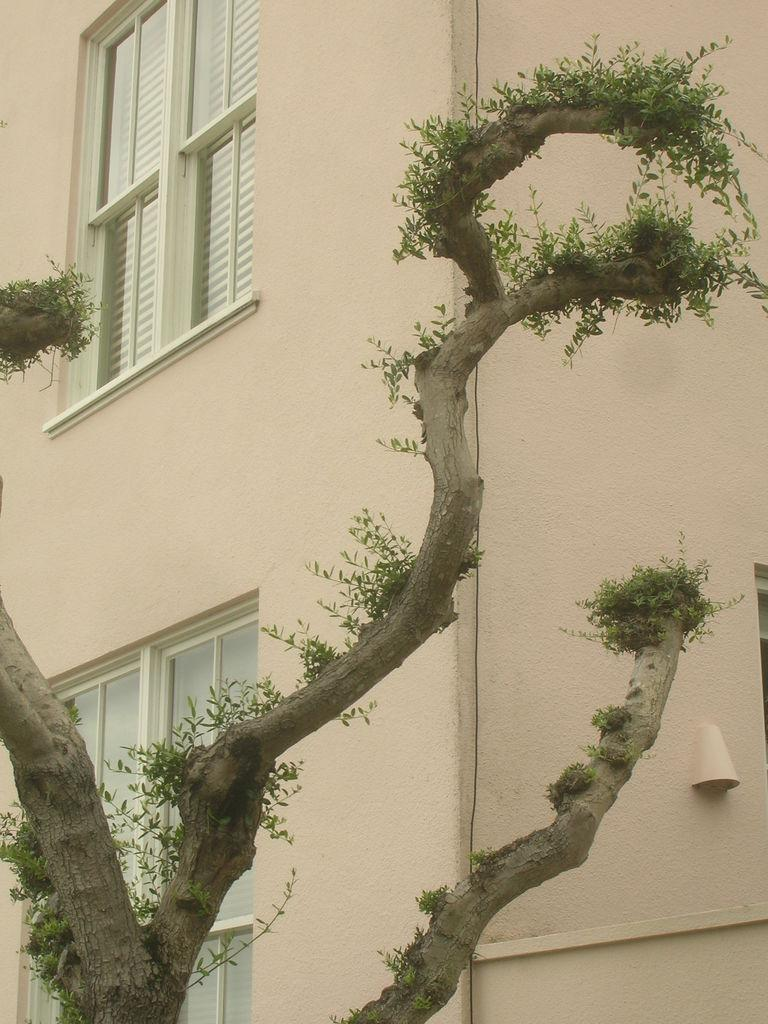What type of structure is present in the image? There is a building in the image. What feature can be seen on the building? There are windows on the building. What natural element is visible in the image? There is a tree visible in the image. How many birds are sitting on the tree in the image? There are no birds present in the image; only the building and tree are visible. What day of the week is depicted in the image? The image does not depict a specific day of the week; it is a static representation of a building and a tree. 